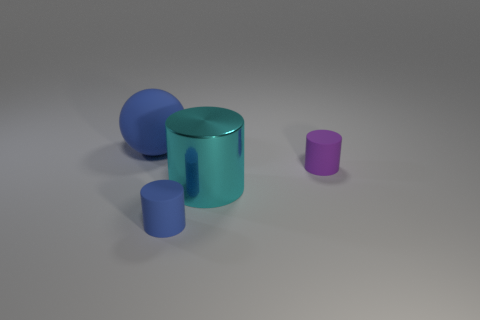Subtract all tiny blue matte cylinders. How many cylinders are left? 2 Add 4 small cylinders. How many objects exist? 8 Subtract all cyan cylinders. How many cylinders are left? 2 Subtract all purple cubes. How many green cylinders are left? 0 Subtract all cylinders. Subtract all small green rubber blocks. How many objects are left? 1 Add 1 cyan metallic cylinders. How many cyan metallic cylinders are left? 2 Add 4 cyan objects. How many cyan objects exist? 5 Subtract 0 green cylinders. How many objects are left? 4 Subtract all cylinders. How many objects are left? 1 Subtract all yellow balls. Subtract all purple cubes. How many balls are left? 1 